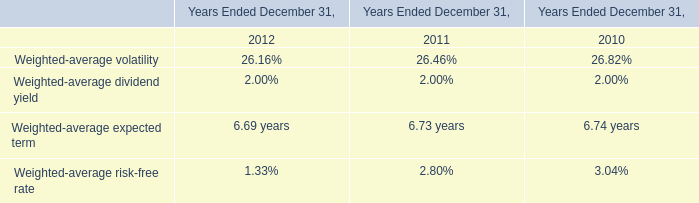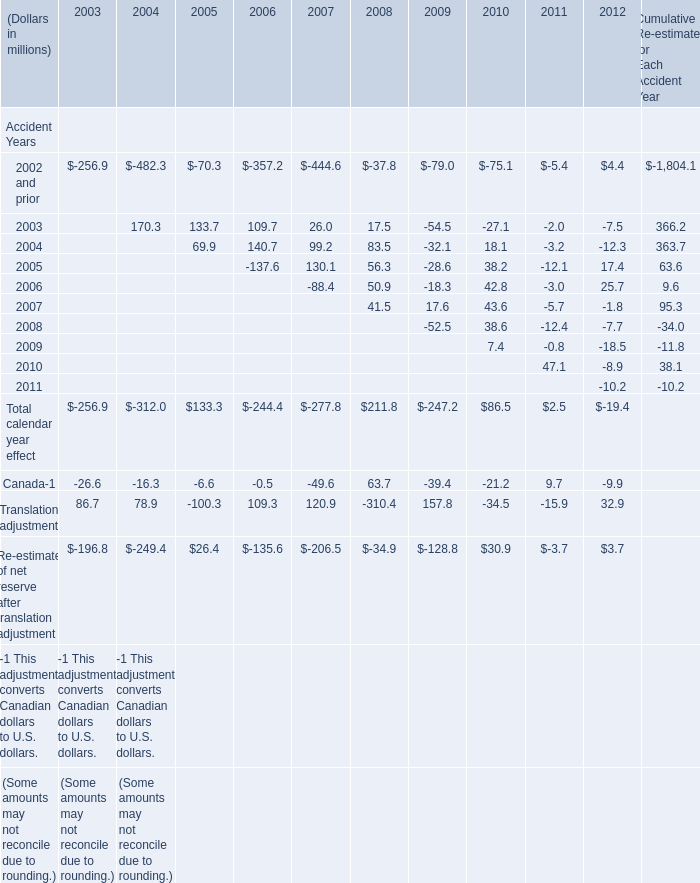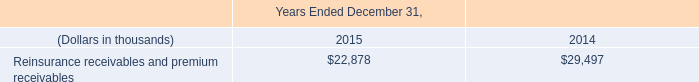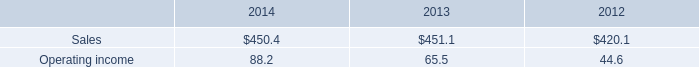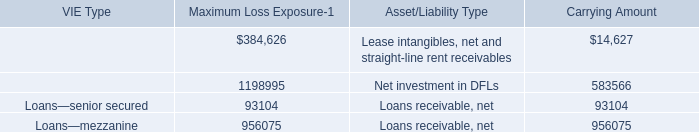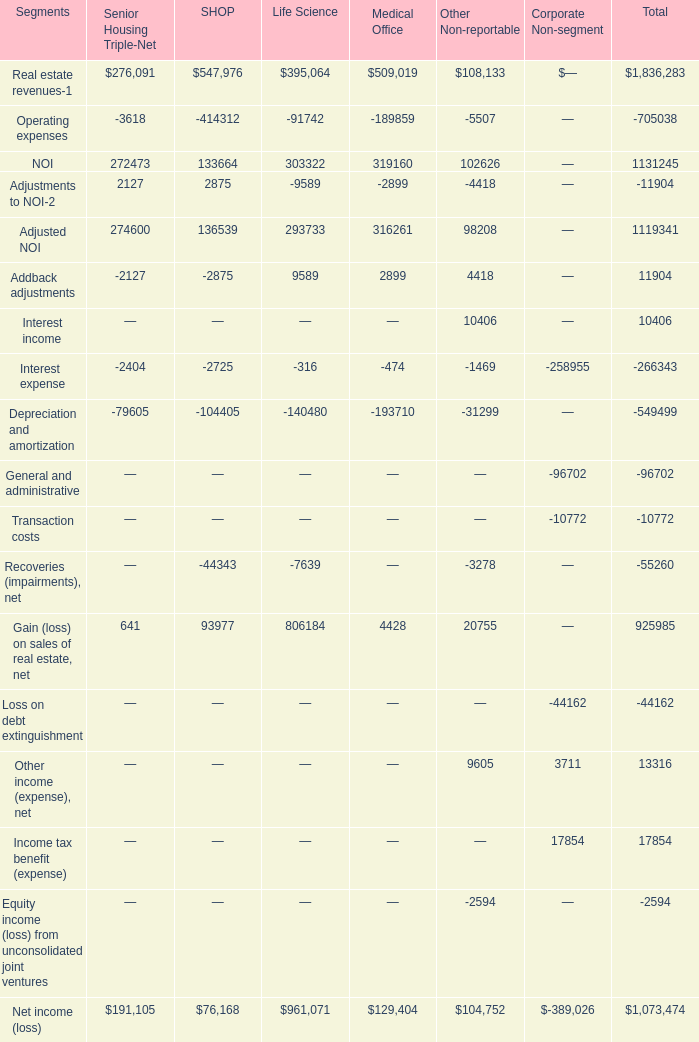What is the average amount of Addback adjustments of Life Science, and VIE tenants—operating leases of Carrying Amount ? 
Computations: ((9589.0 + 14627.0) / 2)
Answer: 12108.0. 